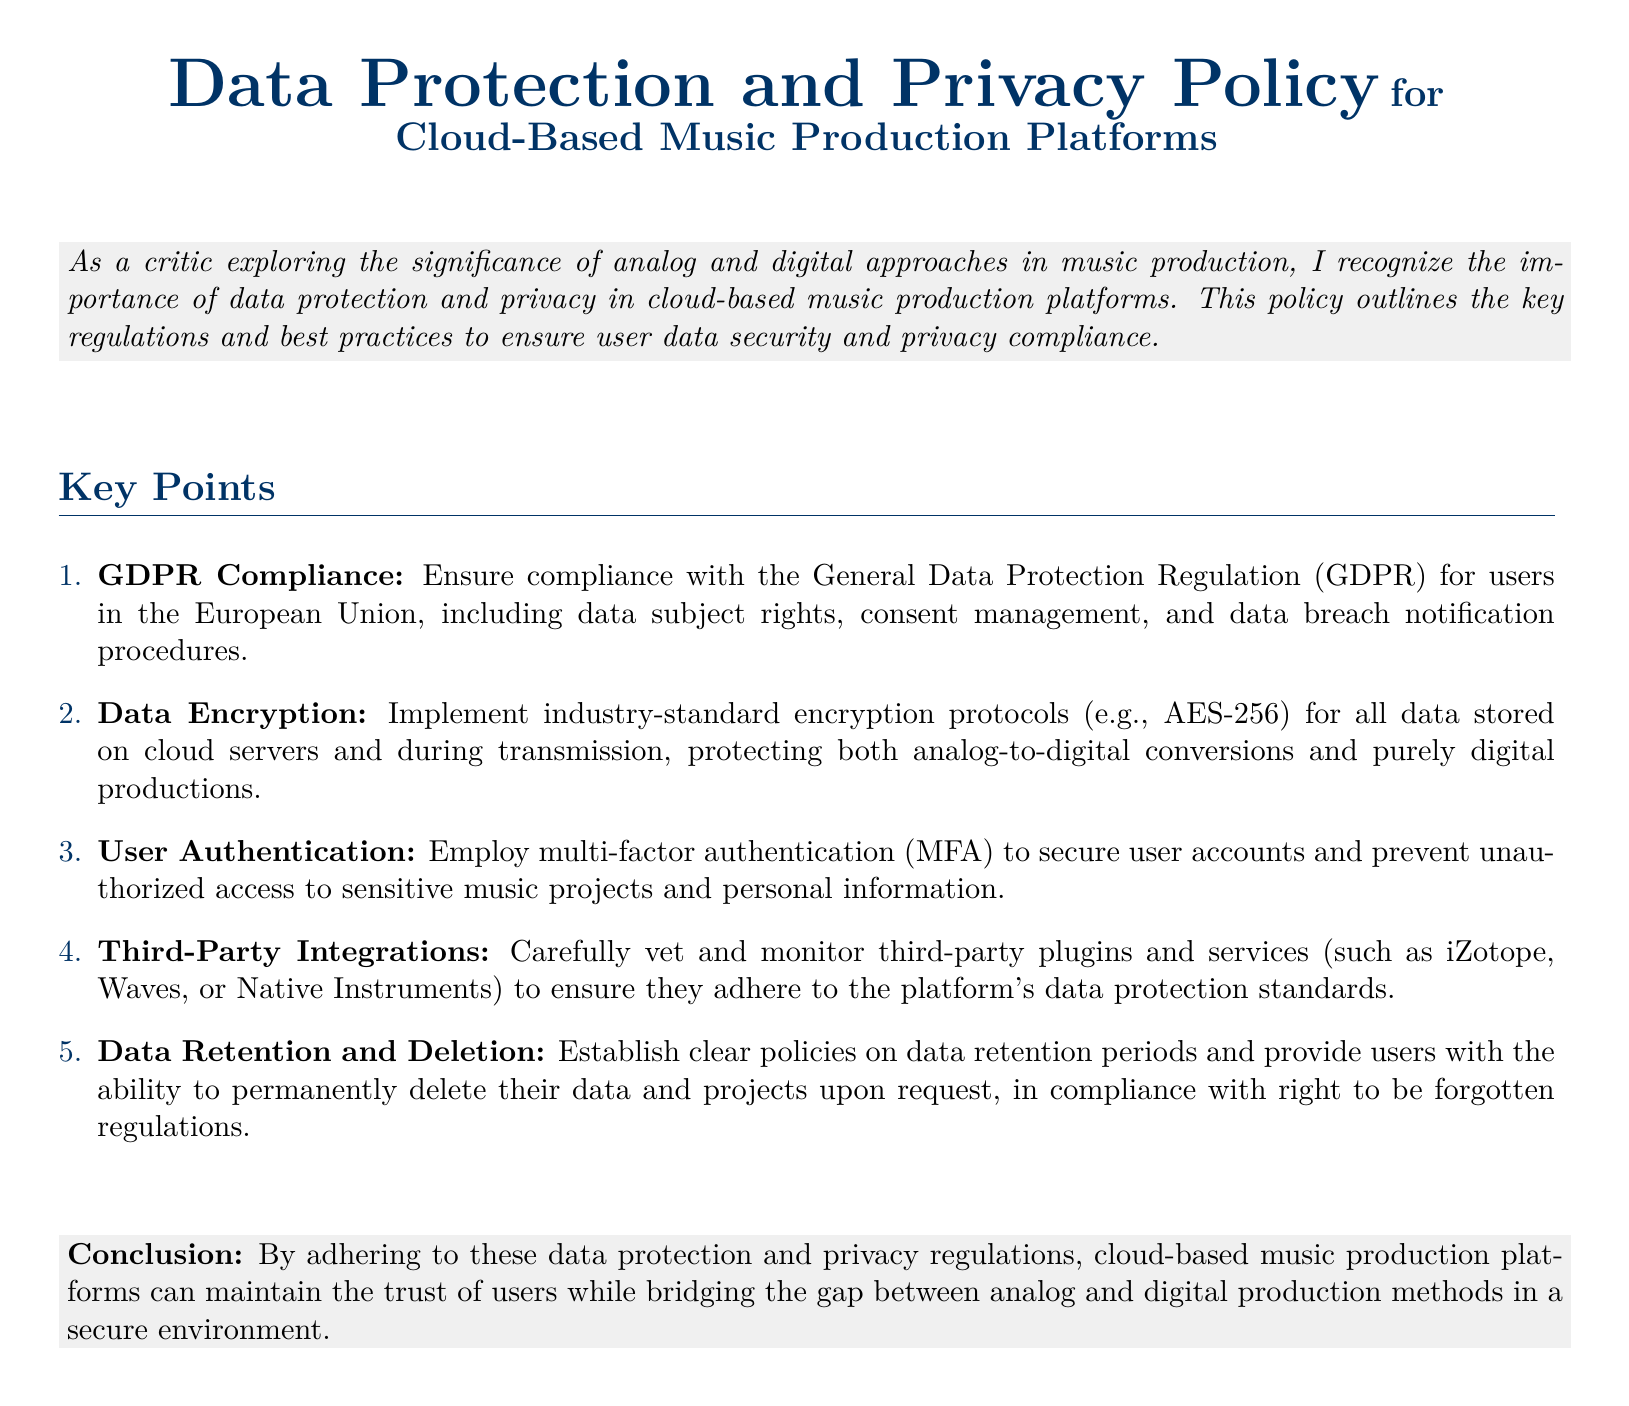What regulation must cloud-based music platforms comply with for EU users? The regulation specified for EU users in the document is the General Data Protection Regulation.
Answer: GDPR What encryption standard is recommended in the policy? The document mentions implementing industry-standard encryption protocols, specifically AES-256.
Answer: AES-256 What type of authentication should be employed for user accounts? The document specifies the use of multi-factor authentication to secure user accounts.
Answer: Multi-factor authentication What should be done to ensure third-party integrations comply with data protection? The policy states that third-party plugins and services should be carefully vetted and monitored for adherence to data protection standards.
Answer: Vet and monitor What right allows users to delete their data and projects permanently? The document indicates compliance with the right to be forgotten, allowing users to permanently delete their data upon request.
Answer: Right to be forgotten How many key points are listed in the policy? The document enumerates five key points outlining the regulations and best practices.
Answer: Five 